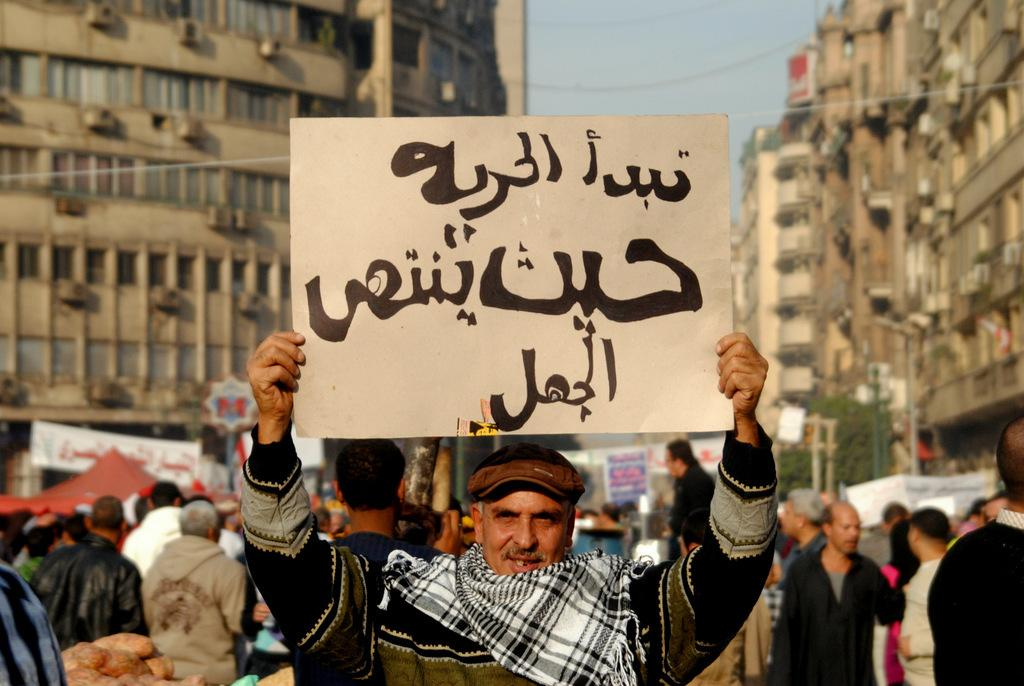What are the people in the image doing? People are protesting in the image. What is one person holding in the image? A person is holding a placard in the image. What can be seen in the distance behind the protesters? There are buildings, trees, poles, and banners visible in the background. What type of furniture can be seen in the image? There is no furniture present in the image; it features people protesting with a placard and various background elements. What insect is crawling on the banner in the image? There are no insects visible in the image. 